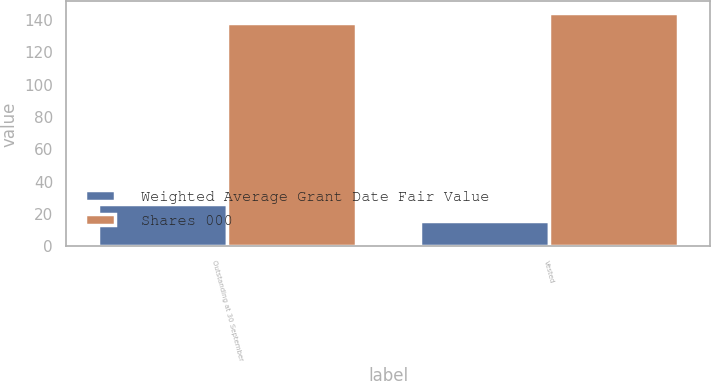<chart> <loc_0><loc_0><loc_500><loc_500><stacked_bar_chart><ecel><fcel>Outstanding at 30 September<fcel>Vested<nl><fcel>Weighted Average Grant Date Fair Value<fcel>26<fcel>16<nl><fcel>Shares 000<fcel>138<fcel>144.09<nl></chart> 